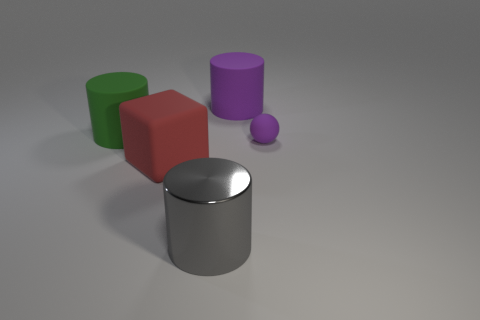Add 1 small gray shiny cylinders. How many objects exist? 6 Subtract all cylinders. How many objects are left? 2 Subtract 0 green balls. How many objects are left? 5 Subtract all small things. Subtract all tiny brown matte cylinders. How many objects are left? 4 Add 5 large red cubes. How many large red cubes are left? 6 Add 1 cylinders. How many cylinders exist? 4 